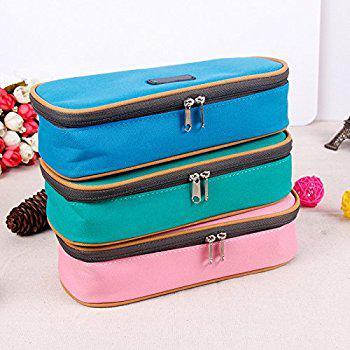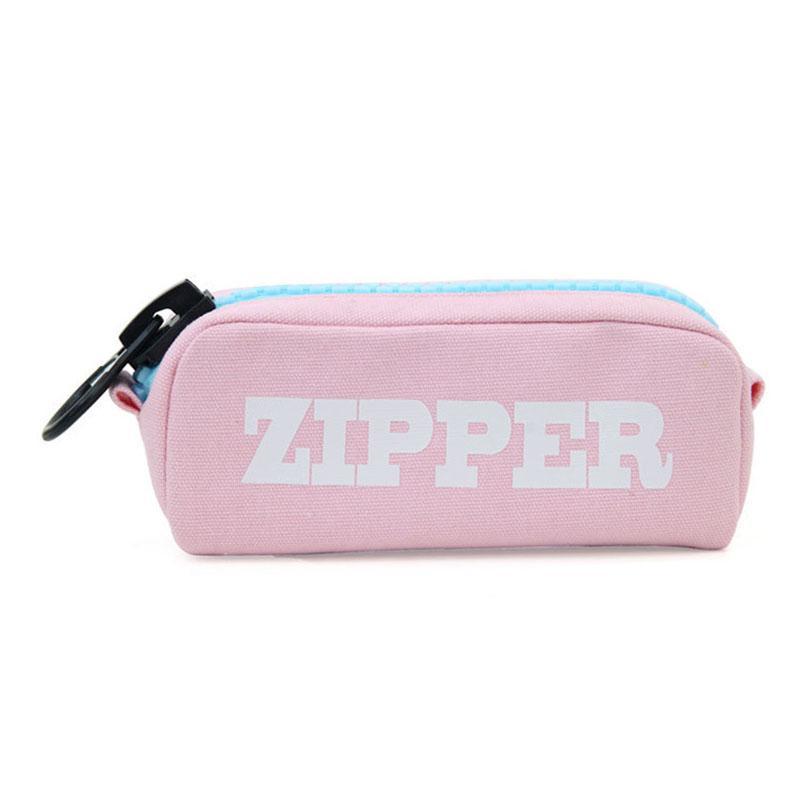The first image is the image on the left, the second image is the image on the right. Given the left and right images, does the statement "An image shows a grouping of at least three pencil cases of the same size." hold true? Answer yes or no. Yes. The first image is the image on the left, the second image is the image on the right. Considering the images on both sides, is "One photo contains three or more pencil cases." valid? Answer yes or no. Yes. 